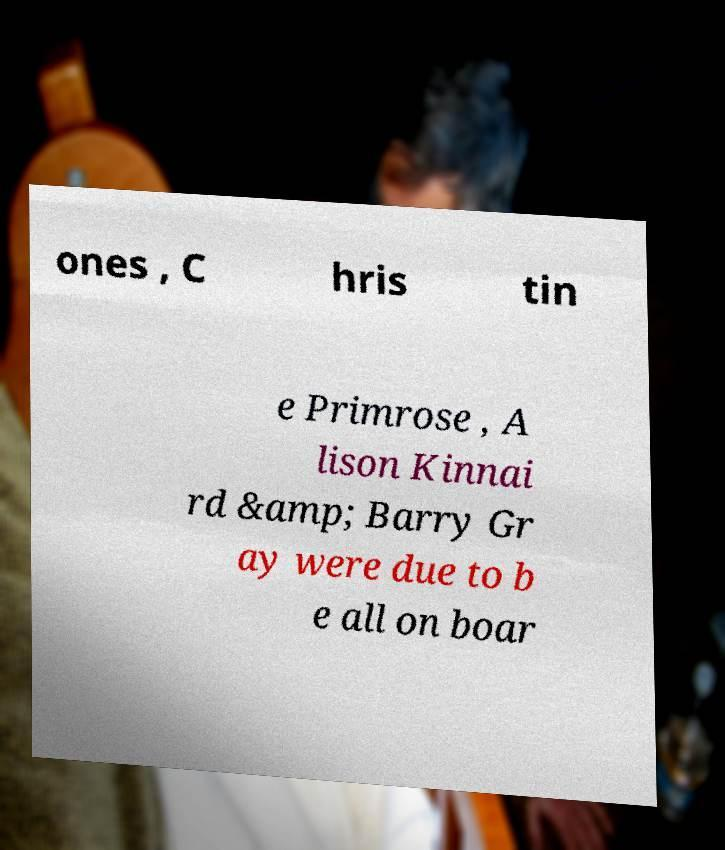Could you extract and type out the text from this image? ones , C hris tin e Primrose , A lison Kinnai rd &amp; Barry Gr ay were due to b e all on boar 